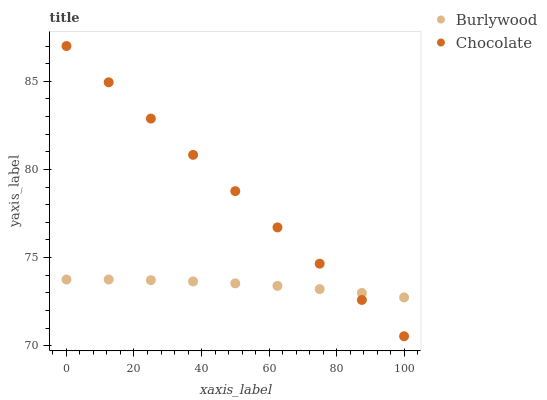Does Burlywood have the minimum area under the curve?
Answer yes or no. Yes. Does Chocolate have the maximum area under the curve?
Answer yes or no. Yes. Does Chocolate have the minimum area under the curve?
Answer yes or no. No. Is Chocolate the smoothest?
Answer yes or no. Yes. Is Burlywood the roughest?
Answer yes or no. Yes. Is Chocolate the roughest?
Answer yes or no. No. Does Chocolate have the lowest value?
Answer yes or no. Yes. Does Chocolate have the highest value?
Answer yes or no. Yes. Does Burlywood intersect Chocolate?
Answer yes or no. Yes. Is Burlywood less than Chocolate?
Answer yes or no. No. Is Burlywood greater than Chocolate?
Answer yes or no. No. 